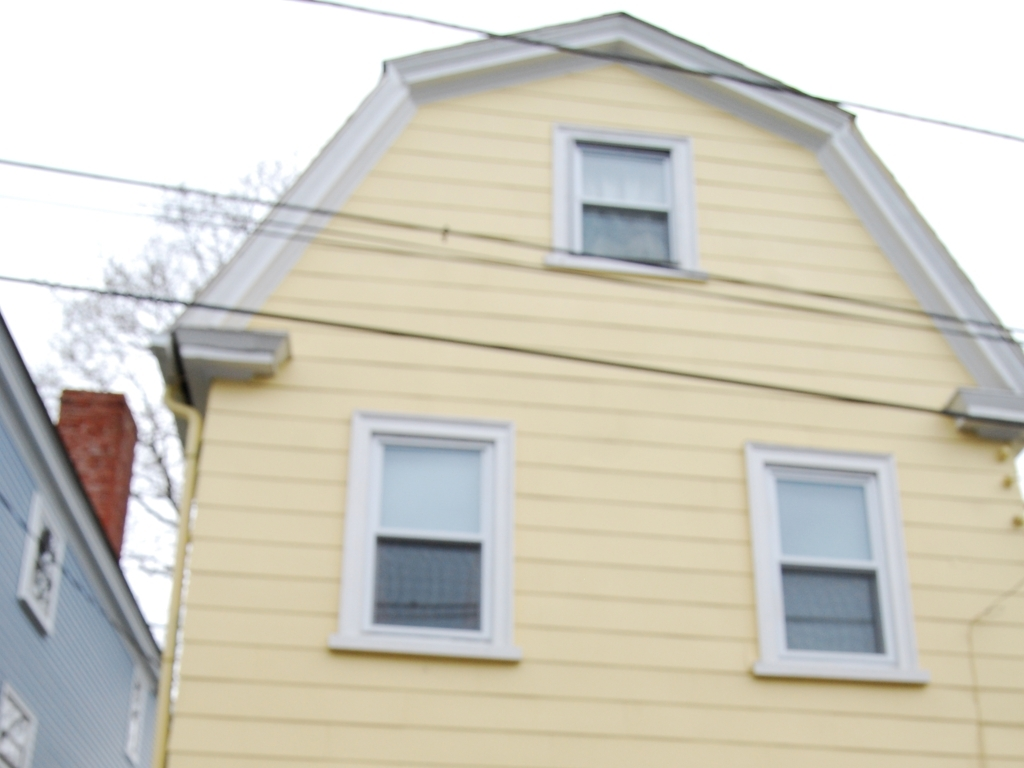Can you describe the style and color of the house? The house features a traditional design, possibly a colonial or a cape cod, with yellow sidings. It has a symmetrical facade with evenly spaced windows on each side, giving it a pleasant and inviting look. 